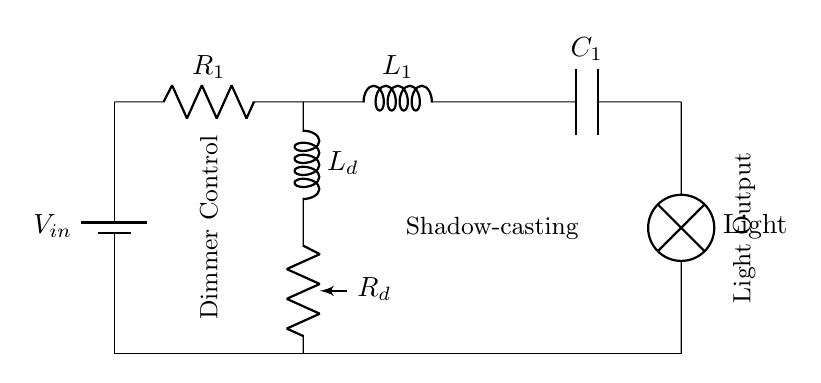What is the input voltage of this circuit? The input voltage is labeled as V_in, representing the voltage supplied to the circuit for operation.
Answer: V_in What type of component is used for lighting? The circuit includes a lamp component, which is specifically utilized to provide light output in the circuit.
Answer: Lamp Which component is responsible for dimming the light? The potentiometer labeled as R_d signifies the dimmer control, allowing for adjustable resistance to regulate the light intensity.
Answer: R_d How many reactive components are included in the circuit? The circuit contains two reactive components: one inductor L_1 and one capacitor C_1. These components store energy in magnetic and electric fields, respectively.
Answer: Two What happens to the voltage across R_d as it's adjusted? As the resistance of R_d is increased, the voltage drop across it increases, leading to less voltage across the lamp, thereby dimming the light. The relationship follows Ohm's law where higher resistance impacts voltage distribution in the circuit.
Answer: It decreases What is the role of the inductor labeled L_d in the circuit? The inductor L_d acts as a component for managing the inductive reactance in the circuit, which aids in controlling the current and stabilizing voltage levels for effective dimming of the light.
Answer: Managing reactance Which component allows for energy storage in the form of electric potential? The capacitor C_1 is responsible for storing energy in the form of electric potential in the circuit during its operation.
Answer: C_1 